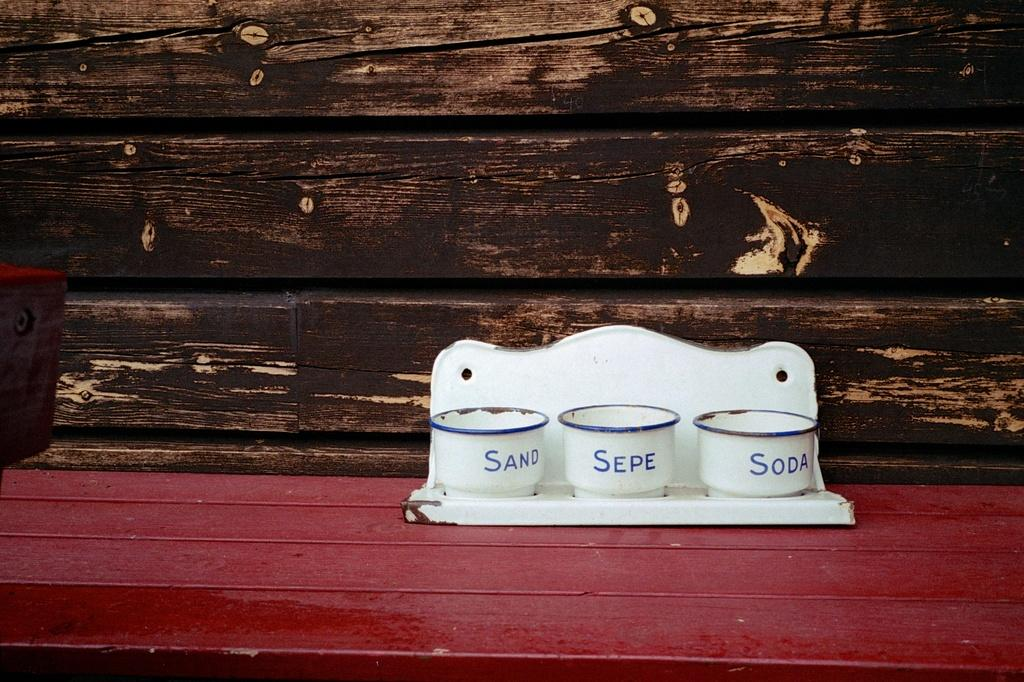How many cups are visible in the image? There are three cups in the image. Where are the cups located? The cups are placed on a bench. What can be seen in the background of the image? The wall in the background appears to be wooden. What type of humor is being displayed by the cups in the image? There is no humor being displayed by the cups in the image; they are simply cups placed on a bench. 